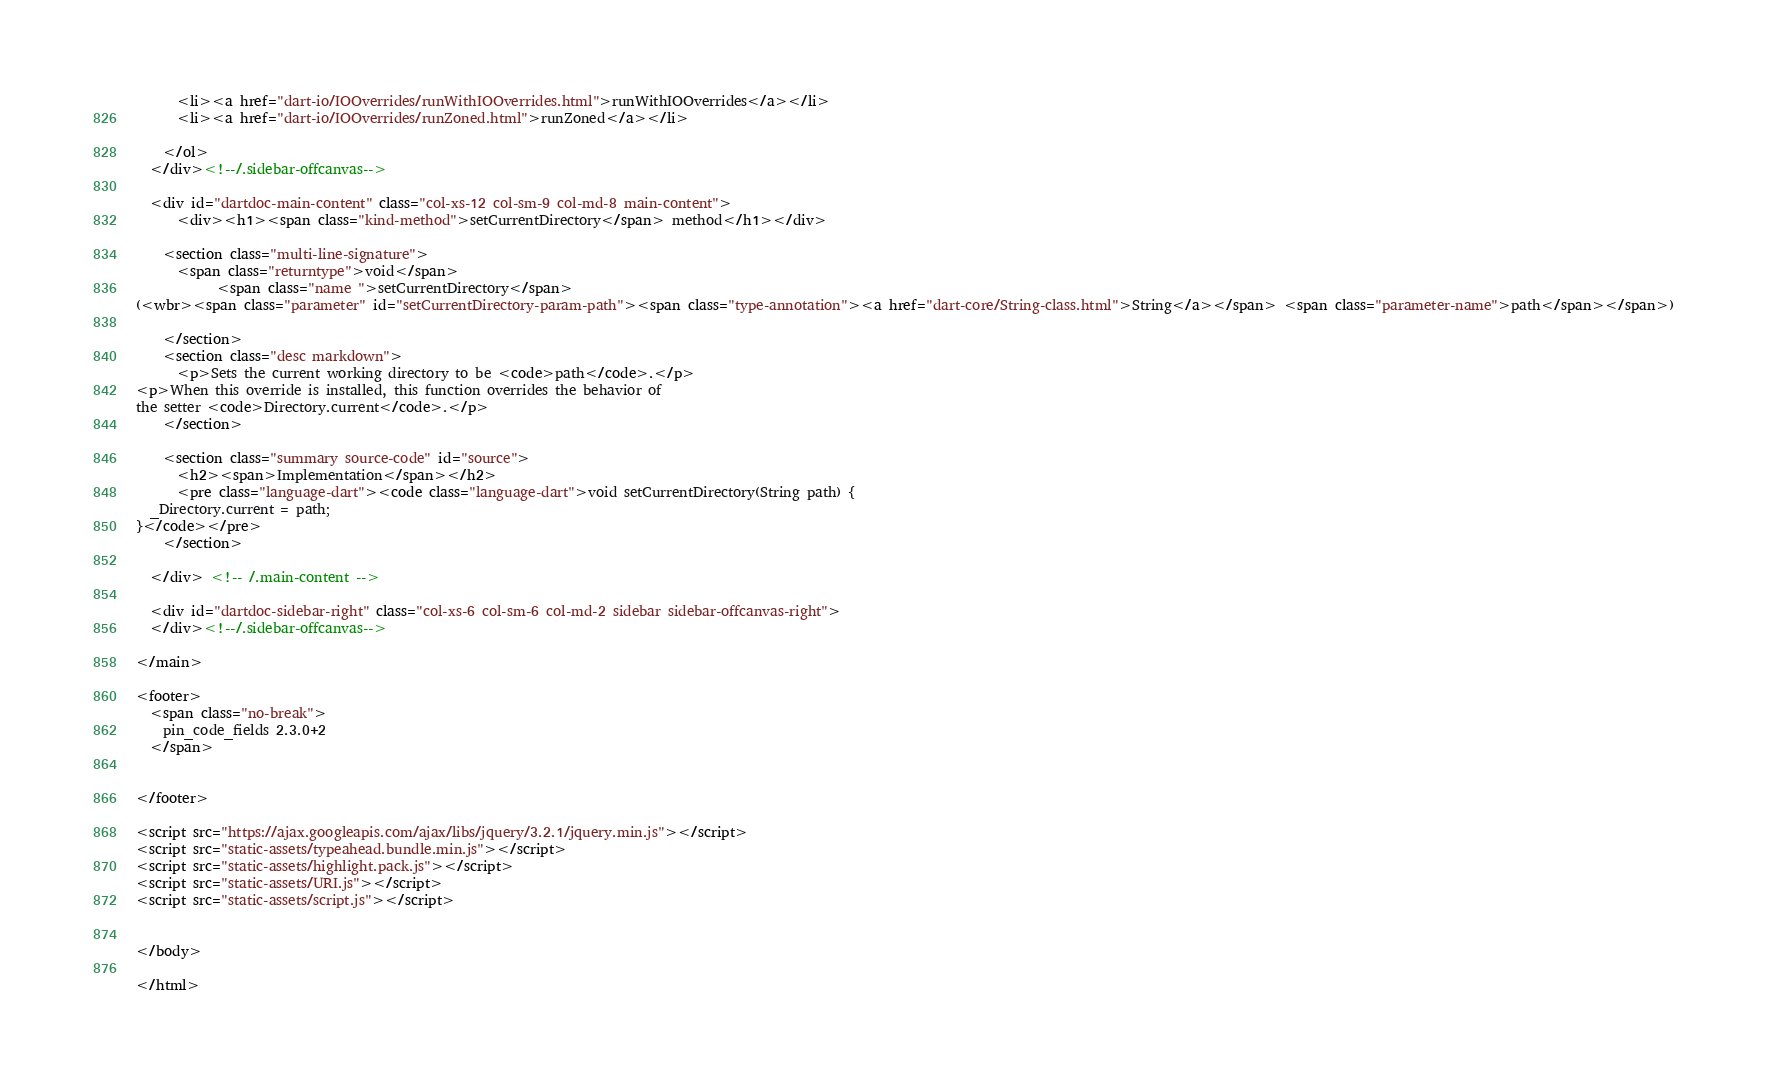Convert code to text. <code><loc_0><loc_0><loc_500><loc_500><_HTML_>      <li><a href="dart-io/IOOverrides/runWithIOOverrides.html">runWithIOOverrides</a></li>
      <li><a href="dart-io/IOOverrides/runZoned.html">runZoned</a></li>
    
    </ol>
  </div><!--/.sidebar-offcanvas-->

  <div id="dartdoc-main-content" class="col-xs-12 col-sm-9 col-md-8 main-content">
      <div><h1><span class="kind-method">setCurrentDirectory</span> method</h1></div>

    <section class="multi-line-signature">
      <span class="returntype">void</span>
            <span class="name ">setCurrentDirectory</span>
(<wbr><span class="parameter" id="setCurrentDirectory-param-path"><span class="type-annotation"><a href="dart-core/String-class.html">String</a></span> <span class="parameter-name">path</span></span>)
      
    </section>
    <section class="desc markdown">
      <p>Sets the current working directory to be <code>path</code>.</p>
<p>When this override is installed, this function overrides the behavior of
the setter <code>Directory.current</code>.</p>
    </section>
    
    <section class="summary source-code" id="source">
      <h2><span>Implementation</span></h2>
      <pre class="language-dart"><code class="language-dart">void setCurrentDirectory(String path) {
  _Directory.current = path;
}</code></pre>
    </section>

  </div> <!-- /.main-content -->

  <div id="dartdoc-sidebar-right" class="col-xs-6 col-sm-6 col-md-2 sidebar sidebar-offcanvas-right">
  </div><!--/.sidebar-offcanvas-->

</main>

<footer>
  <span class="no-break">
    pin_code_fields 2.3.0+2
  </span>

  
</footer>

<script src="https://ajax.googleapis.com/ajax/libs/jquery/3.2.1/jquery.min.js"></script>
<script src="static-assets/typeahead.bundle.min.js"></script>
<script src="static-assets/highlight.pack.js"></script>
<script src="static-assets/URI.js"></script>
<script src="static-assets/script.js"></script>


</body>

</html>
</code> 